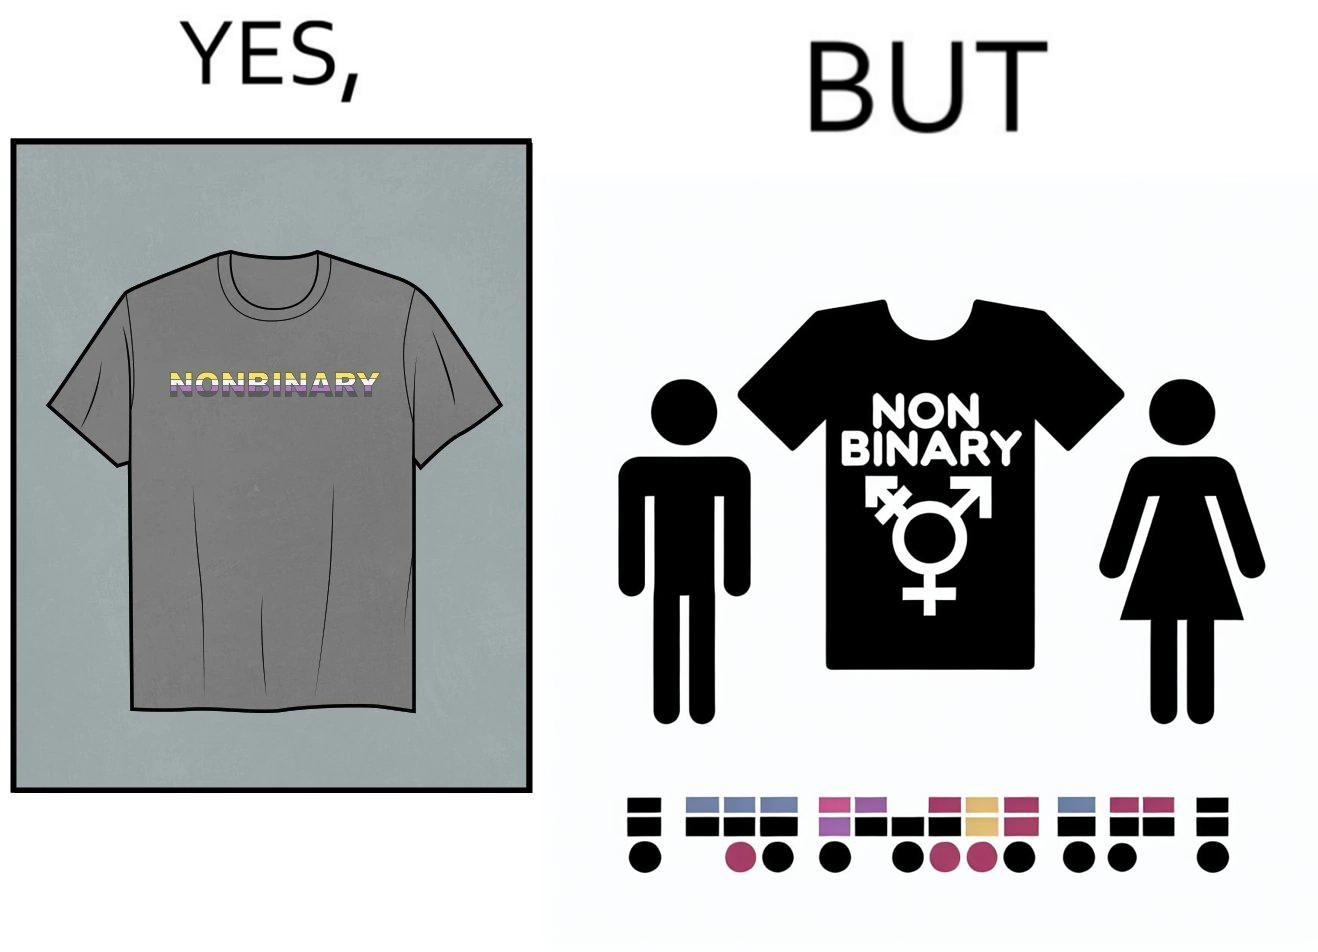What is shown in the left half versus the right half of this image? In the left part of the image: t-shirt with "NONBINARY" written on it. In the right part of the image: t-shirt with "NONBINARY" written on it, with several customizable options for color and 2 gender options on the right 